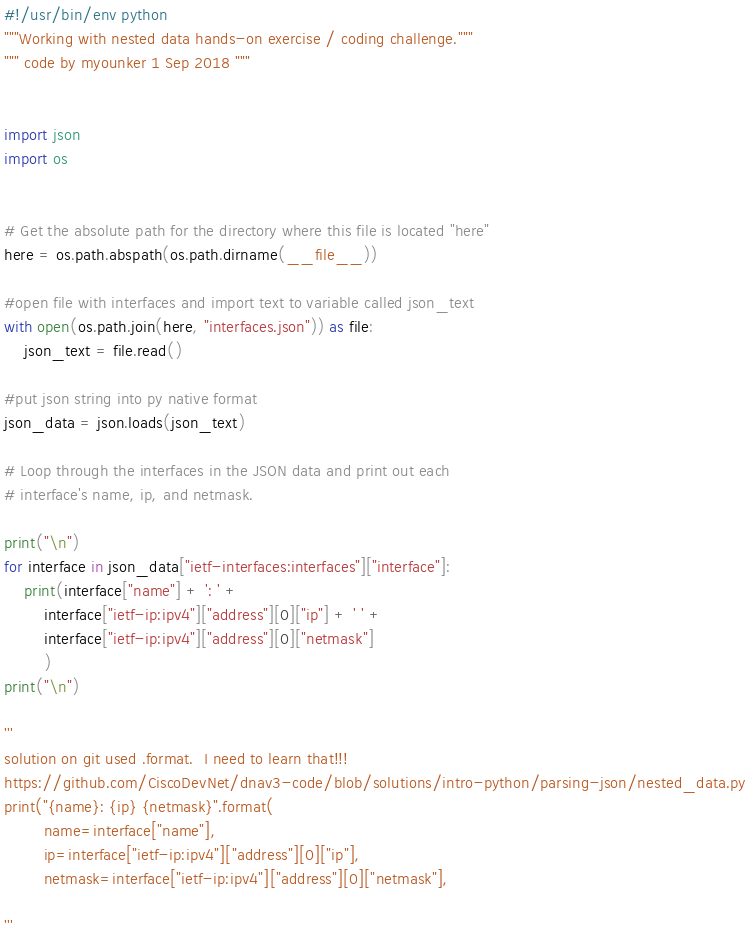<code> <loc_0><loc_0><loc_500><loc_500><_Python_>#!/usr/bin/env python
"""Working with nested data hands-on exercise / coding challenge."""
""" code by myounker 1 Sep 2018 """


import json
import os


# Get the absolute path for the directory where this file is located "here"
here = os.path.abspath(os.path.dirname(__file__))

#open file with interfaces and import text to variable called json_text
with open(os.path.join(here, "interfaces.json")) as file:
    json_text = file.read()

#put json string into py native format
json_data = json.loads(json_text)

# Loop through the interfaces in the JSON data and print out each
# interface's name, ip, and netmask.

print("\n")
for interface in json_data["ietf-interfaces:interfaces"]["interface"]:
    print(interface["name"] + ': ' +
        interface["ietf-ip:ipv4"]["address"][0]["ip"] + ' ' +
        interface["ietf-ip:ipv4"]["address"][0]["netmask"]
        )
print("\n")

'''
solution on git used .format.  I need to learn that!!!
https://github.com/CiscoDevNet/dnav3-code/blob/solutions/intro-python/parsing-json/nested_data.py
print("{name}: {ip} {netmask}".format(
        name=interface["name"],
        ip=interface["ietf-ip:ipv4"]["address"][0]["ip"],
        netmask=interface["ietf-ip:ipv4"]["address"][0]["netmask"],

'''
</code> 